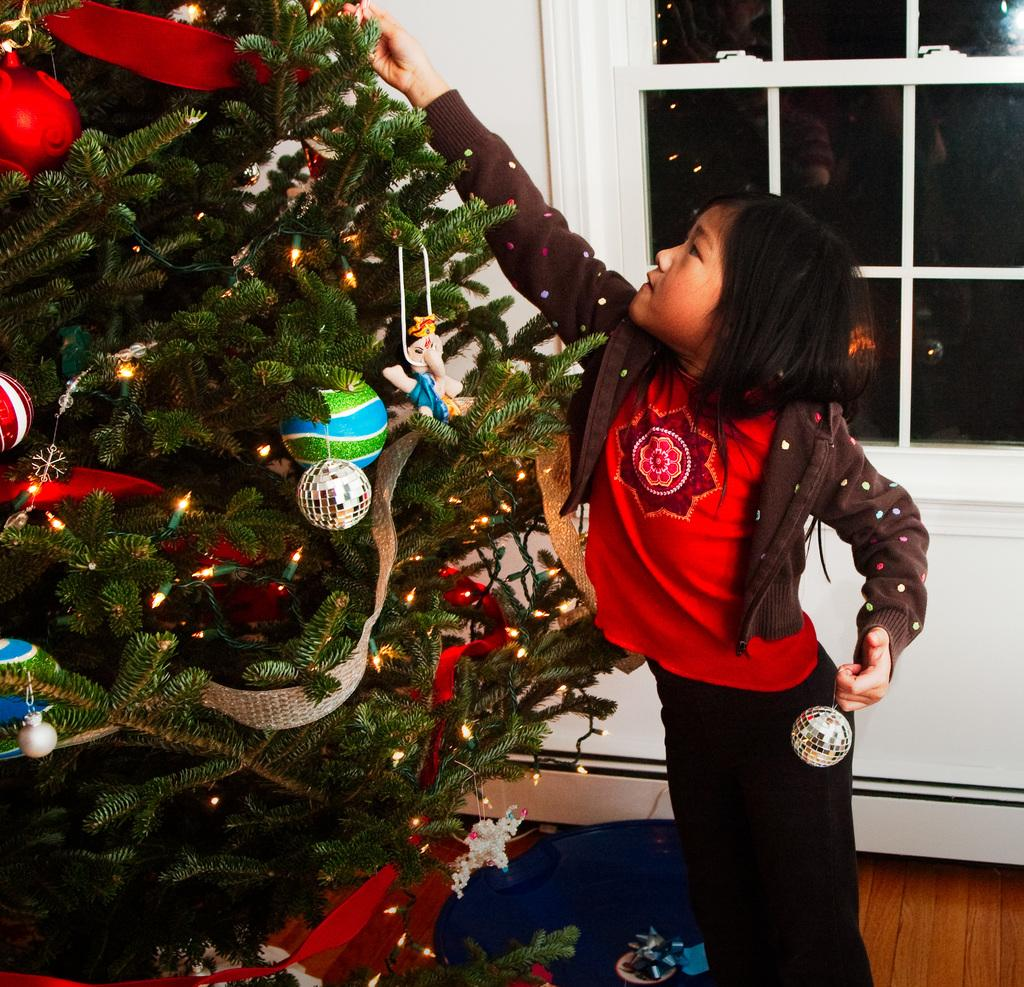What is the main object in the image? There is a Christmas tree in the image. How is the Christmas tree decorated? The Christmas tree has decorative items and lights on it. What can be found near the entrance of the room in the image? There is a doormat in the image. Who is present in the room in the image? There is a girl standing on the floor in the image. What can be seen in the background of the room? There is a window and a wall in the background of the image. What type of quill is the girl using to write a good-bye note in the image? There is no quill or note-writing activity present in the image. 